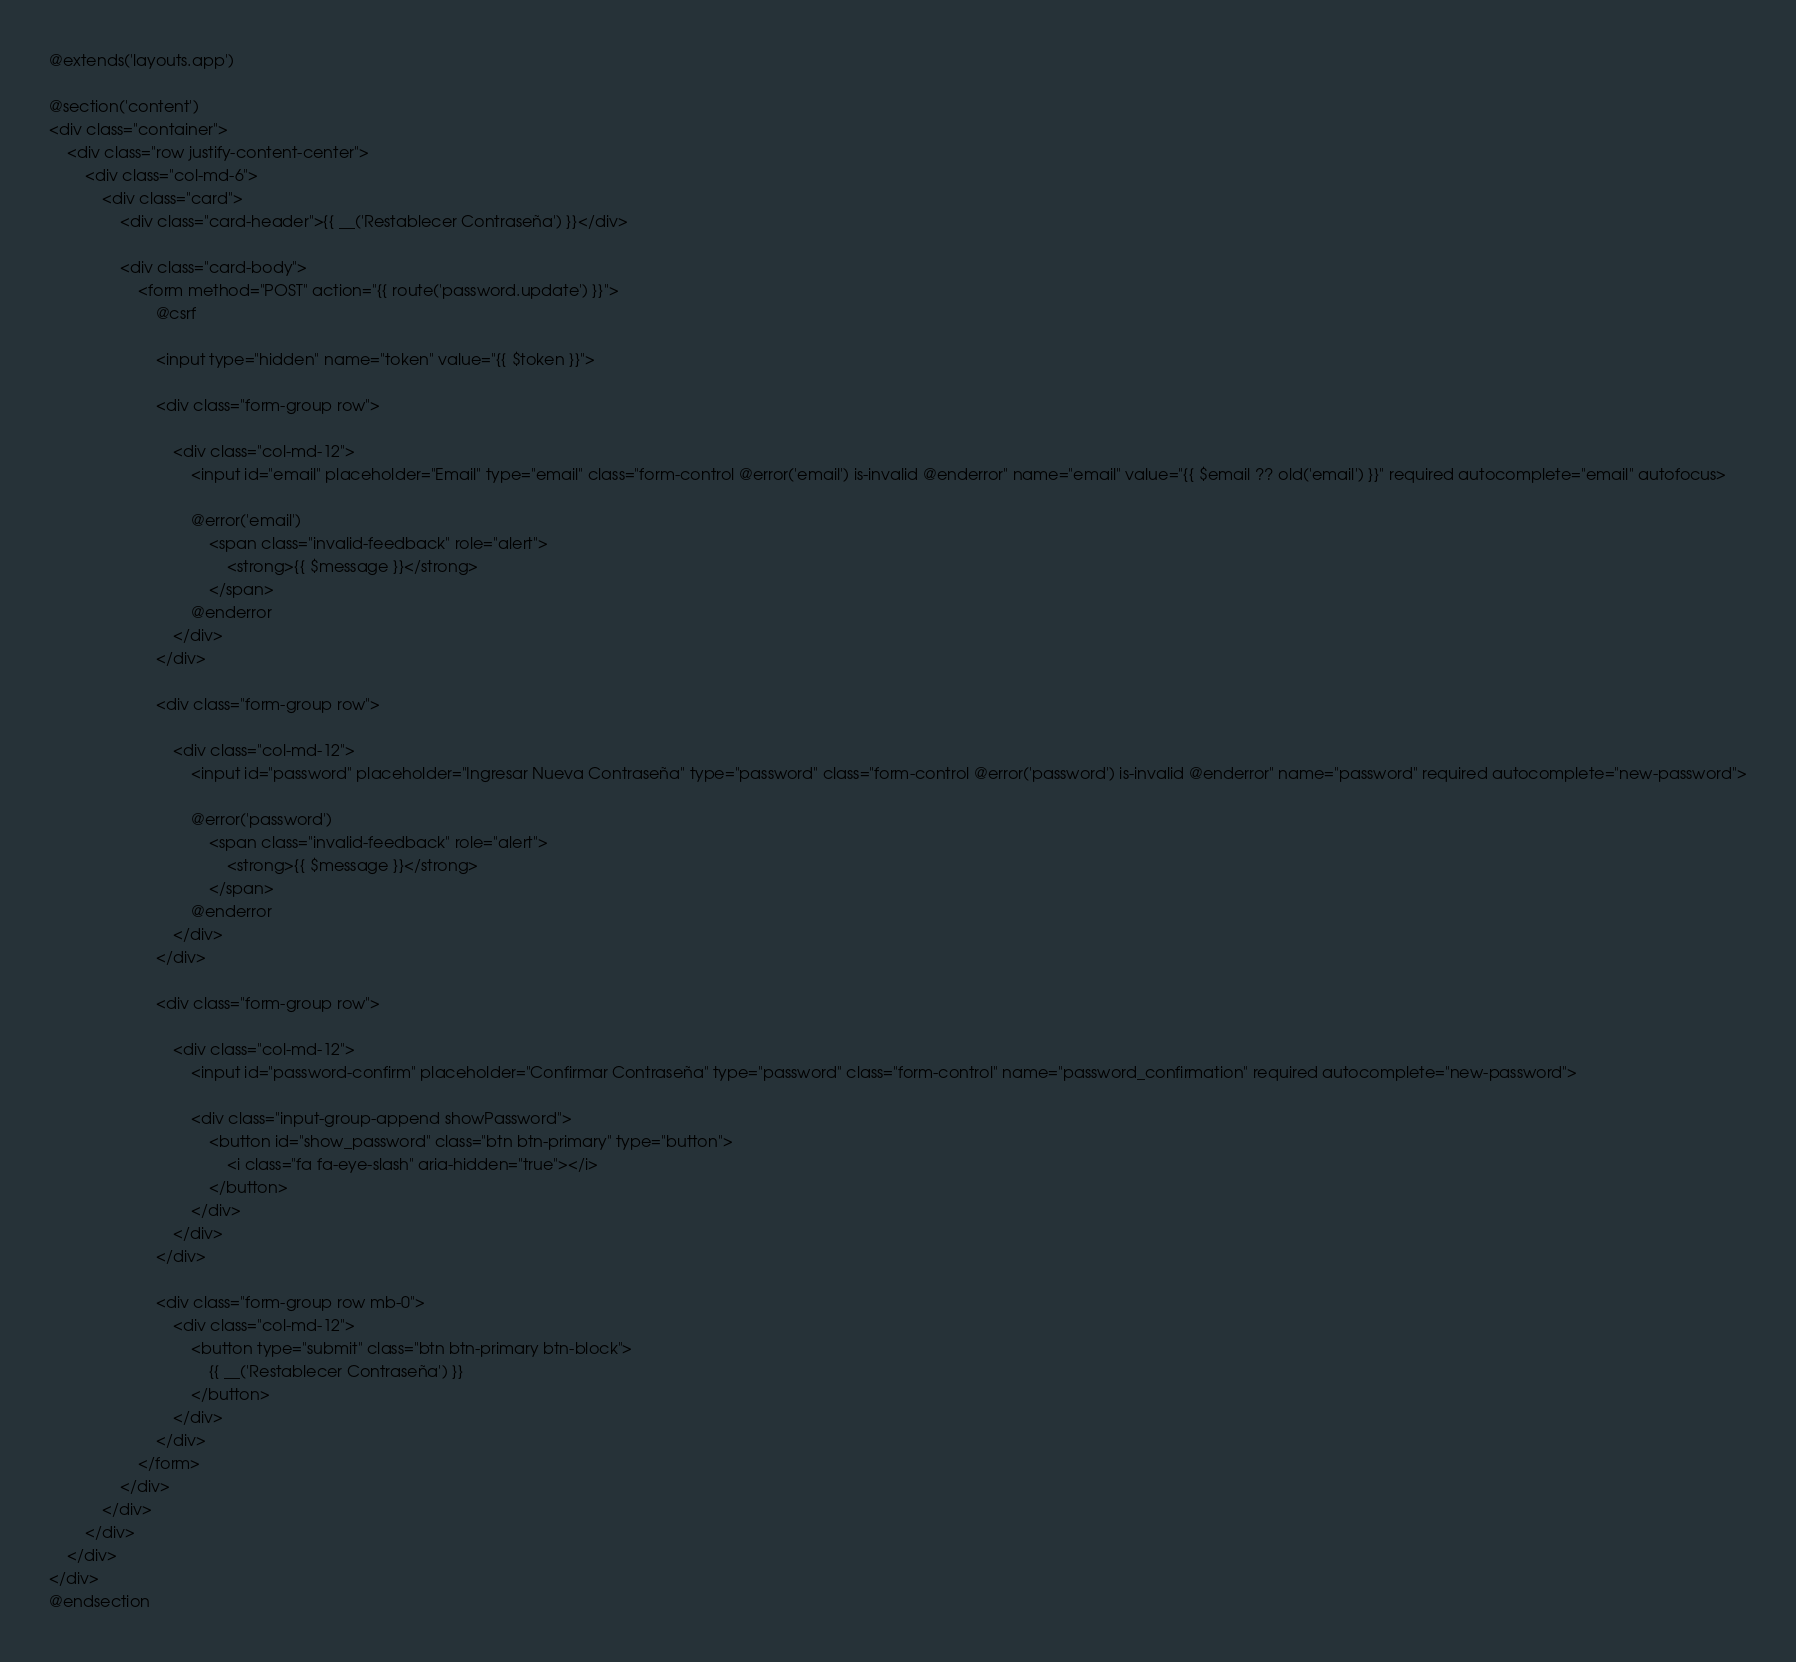Convert code to text. <code><loc_0><loc_0><loc_500><loc_500><_PHP_>@extends('layouts.app')

@section('content')
<div class="container">
    <div class="row justify-content-center">
        <div class="col-md-6">
            <div class="card">
                <div class="card-header">{{ __('Restablecer Contraseña') }}</div>

                <div class="card-body">
                    <form method="POST" action="{{ route('password.update') }}">
                        @csrf

                        <input type="hidden" name="token" value="{{ $token }}">

                        <div class="form-group row">                            

                            <div class="col-md-12">
                                <input id="email" placeholder="Email" type="email" class="form-control @error('email') is-invalid @enderror" name="email" value="{{ $email ?? old('email') }}" required autocomplete="email" autofocus>

                                @error('email')
                                    <span class="invalid-feedback" role="alert">
                                        <strong>{{ $message }}</strong>
                                    </span>
                                @enderror
                            </div>
                        </div>

                        <div class="form-group row">                           

                            <div class="col-md-12">
                                <input id="password" placeholder="Ingresar Nueva Contraseña" type="password" class="form-control @error('password') is-invalid @enderror" name="password" required autocomplete="new-password">

                                @error('password')
                                    <span class="invalid-feedback" role="alert">
                                        <strong>{{ $message }}</strong>
                                    </span>
                                @enderror
                            </div>
                        </div>

                        <div class="form-group row">                            

                            <div class="col-md-12">
                                <input id="password-confirm" placeholder="Confirmar Contraseña" type="password" class="form-control" name="password_confirmation" required autocomplete="new-password">

                                <div class="input-group-append showPassword">
                                    <button id="show_password" class="btn btn-primary" type="button">
                                        <i class="fa fa-eye-slash" aria-hidden="true"></i>
                                    </button>
                                </div>
                            </div>
                        </div>

                        <div class="form-group row mb-0">
                            <div class="col-md-12">
                                <button type="submit" class="btn btn-primary btn-block">
                                    {{ __('Restablecer Contraseña') }}
                                </button>
                            </div>
                        </div>
                    </form>
                </div>
            </div>
        </div>
    </div>
</div>
@endsection
</code> 